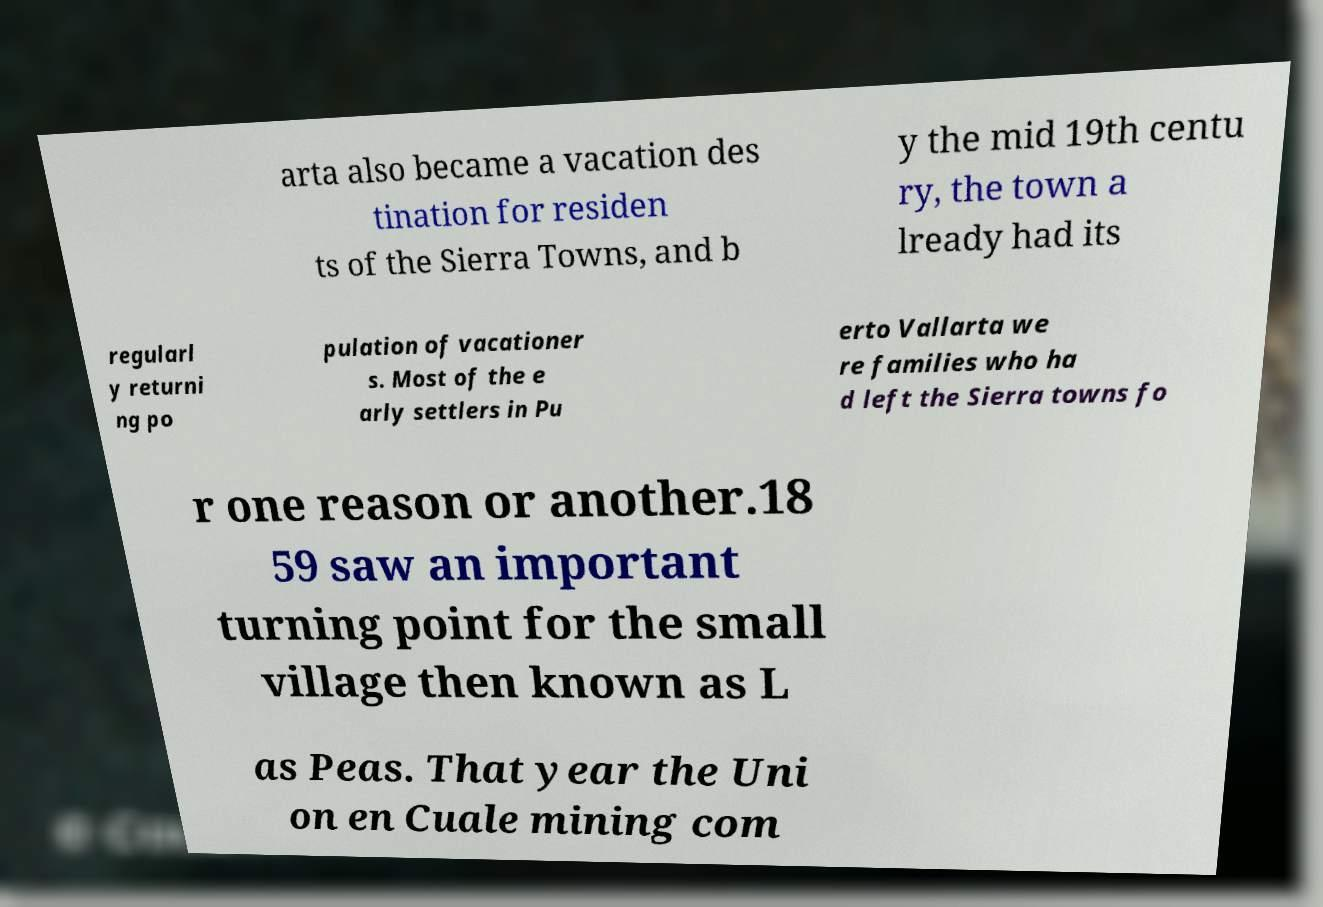There's text embedded in this image that I need extracted. Can you transcribe it verbatim? arta also became a vacation des tination for residen ts of the Sierra Towns, and b y the mid 19th centu ry, the town a lready had its regularl y returni ng po pulation of vacationer s. Most of the e arly settlers in Pu erto Vallarta we re families who ha d left the Sierra towns fo r one reason or another.18 59 saw an important turning point for the small village then known as L as Peas. That year the Uni on en Cuale mining com 